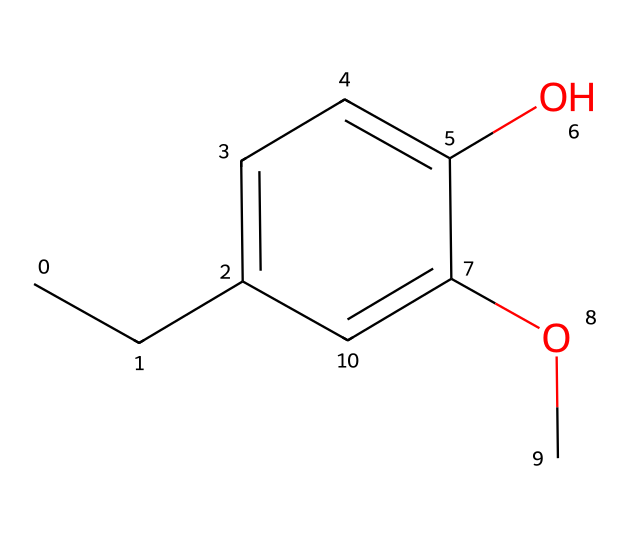What is the molecular formula of eugenol? To determine the molecular formula from the SMILES representation (CCc1ccc(O)c(OC)c1), we count each type of atom present. From the structure, there are 10 carbon (C) atoms, 12 hydrogen (H) atoms, and 3 oxygen (O) atoms, leading to the molecular formula C10H12O3.
Answer: C10H12O3 How many hydroxyl groups (–OH) are present in eugenol? By examining the SMILES, we can identify the –OH group, which is the characteristic functional group in phenols. In the structure CCc1ccc(O)c(OC)c1, there is one –OH group (represented by 'O' directly connected to a carbon atom).
Answer: one What type of reaction is eugenol commonly involved in due to its phenolic nature? Eugenol, being a phenol, is likely to participate in reactions characteristic of phenolic compounds, such as electrophilic aromatic substitution or oxidation. These reactions are facilitated due to the presence of the hydroxyl group that alters the reactivity of the aromatic ring.
Answer: electrophilic aromatic substitution How many carbon atoms are in the longest carbon chain of eugenol? The longest continuous carbon chain can be identified in the SMILES by tracing the carbon sequence. The chain consists of three carbons (from CC) plus the two in the aromatic ring, leading to a total of five carbons in the longest chain.
Answer: five What functional group contributes to the aroma of eugenol? The aromatic ring (which is part of the phenolic structure) and the –OCH3 group (methoxy) both play key roles in the aroma attributed to eugenol. The presence of these groups is essential in the flavor profile typical of eugenol.
Answer: aromatic ring What is the significance of the methoxy group in eugenol? The methoxy group (-OCH3) can influence both the chemical properties and the aroma of eugenol. The presence of this group enhances the solubility of eugenol in organic solvents and contributes to its sweet, spicy flavor profile.
Answer: enhances aroma and solubility 